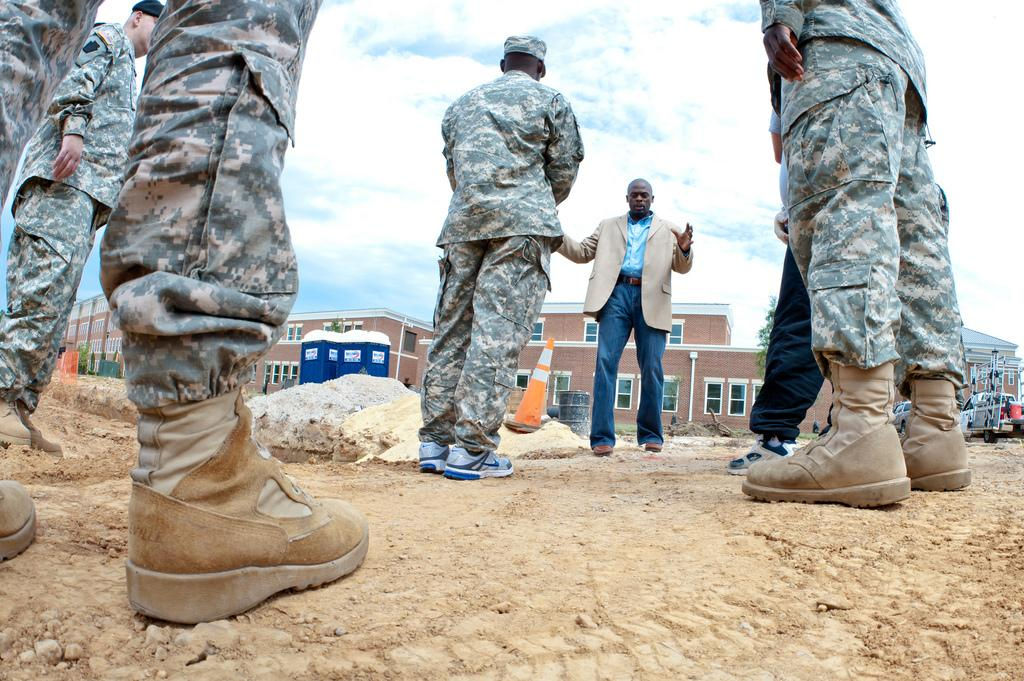Who or what can be seen in the image? There are people in the image. What type of structures are visible in the image? There are buildings in the image. What else can be seen moving in the image? There are vehicles in the image. What is the surface that the people, buildings, and vehicles are on or near? The ground is visible in the image. Are there any objects placed on the ground? Yes, there are objects on the ground. What can be seen above the people, buildings, and vehicles? The sky is visible in the image. What is the condition of the sky in the image? There are clouds in the sky. What type of ink is being used to draw on the pot in the image? There is no pot or ink present in the image. What holiday is being celebrated in the image? There is no indication of a holiday being celebrated in the image. 